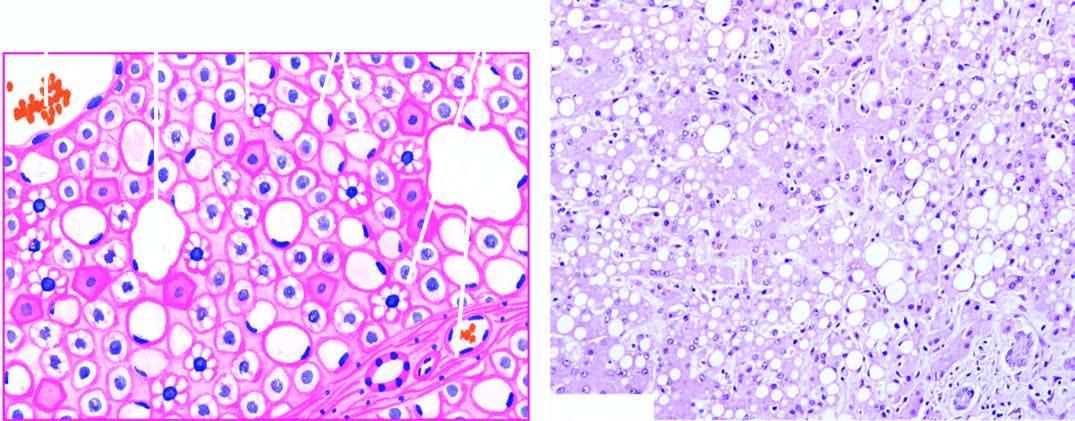what are most of the hepatocytes distended with?
Answer the question using a single word or phrase. Large lipid vacuoles with peripherally displaced nuclei 